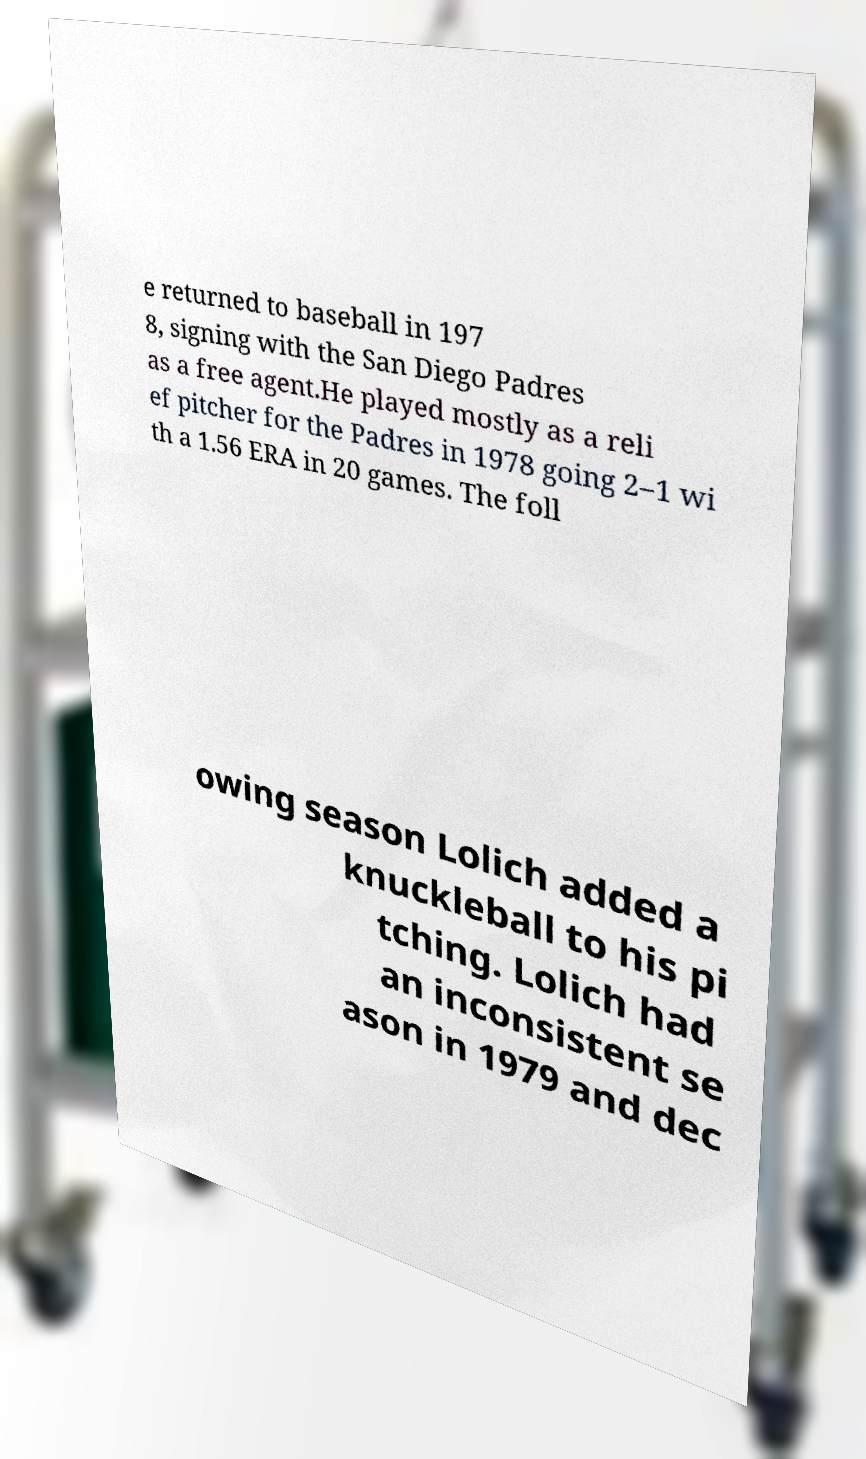There's text embedded in this image that I need extracted. Can you transcribe it verbatim? e returned to baseball in 197 8, signing with the San Diego Padres as a free agent.He played mostly as a reli ef pitcher for the Padres in 1978 going 2–1 wi th a 1.56 ERA in 20 games. The foll owing season Lolich added a knuckleball to his pi tching. Lolich had an inconsistent se ason in 1979 and dec 